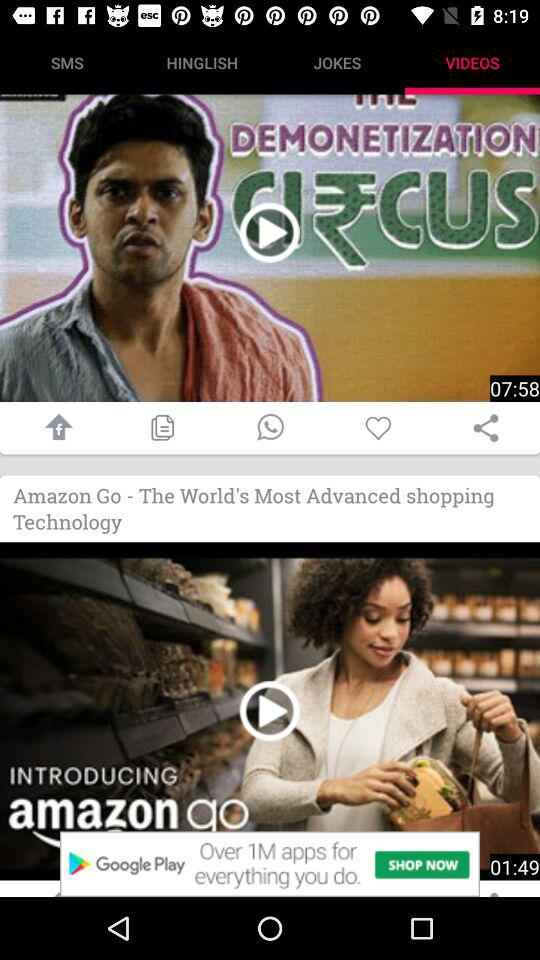What is the time duration of the video on demonetization? The time duration of the video is 7 minutes 58 seconds. 